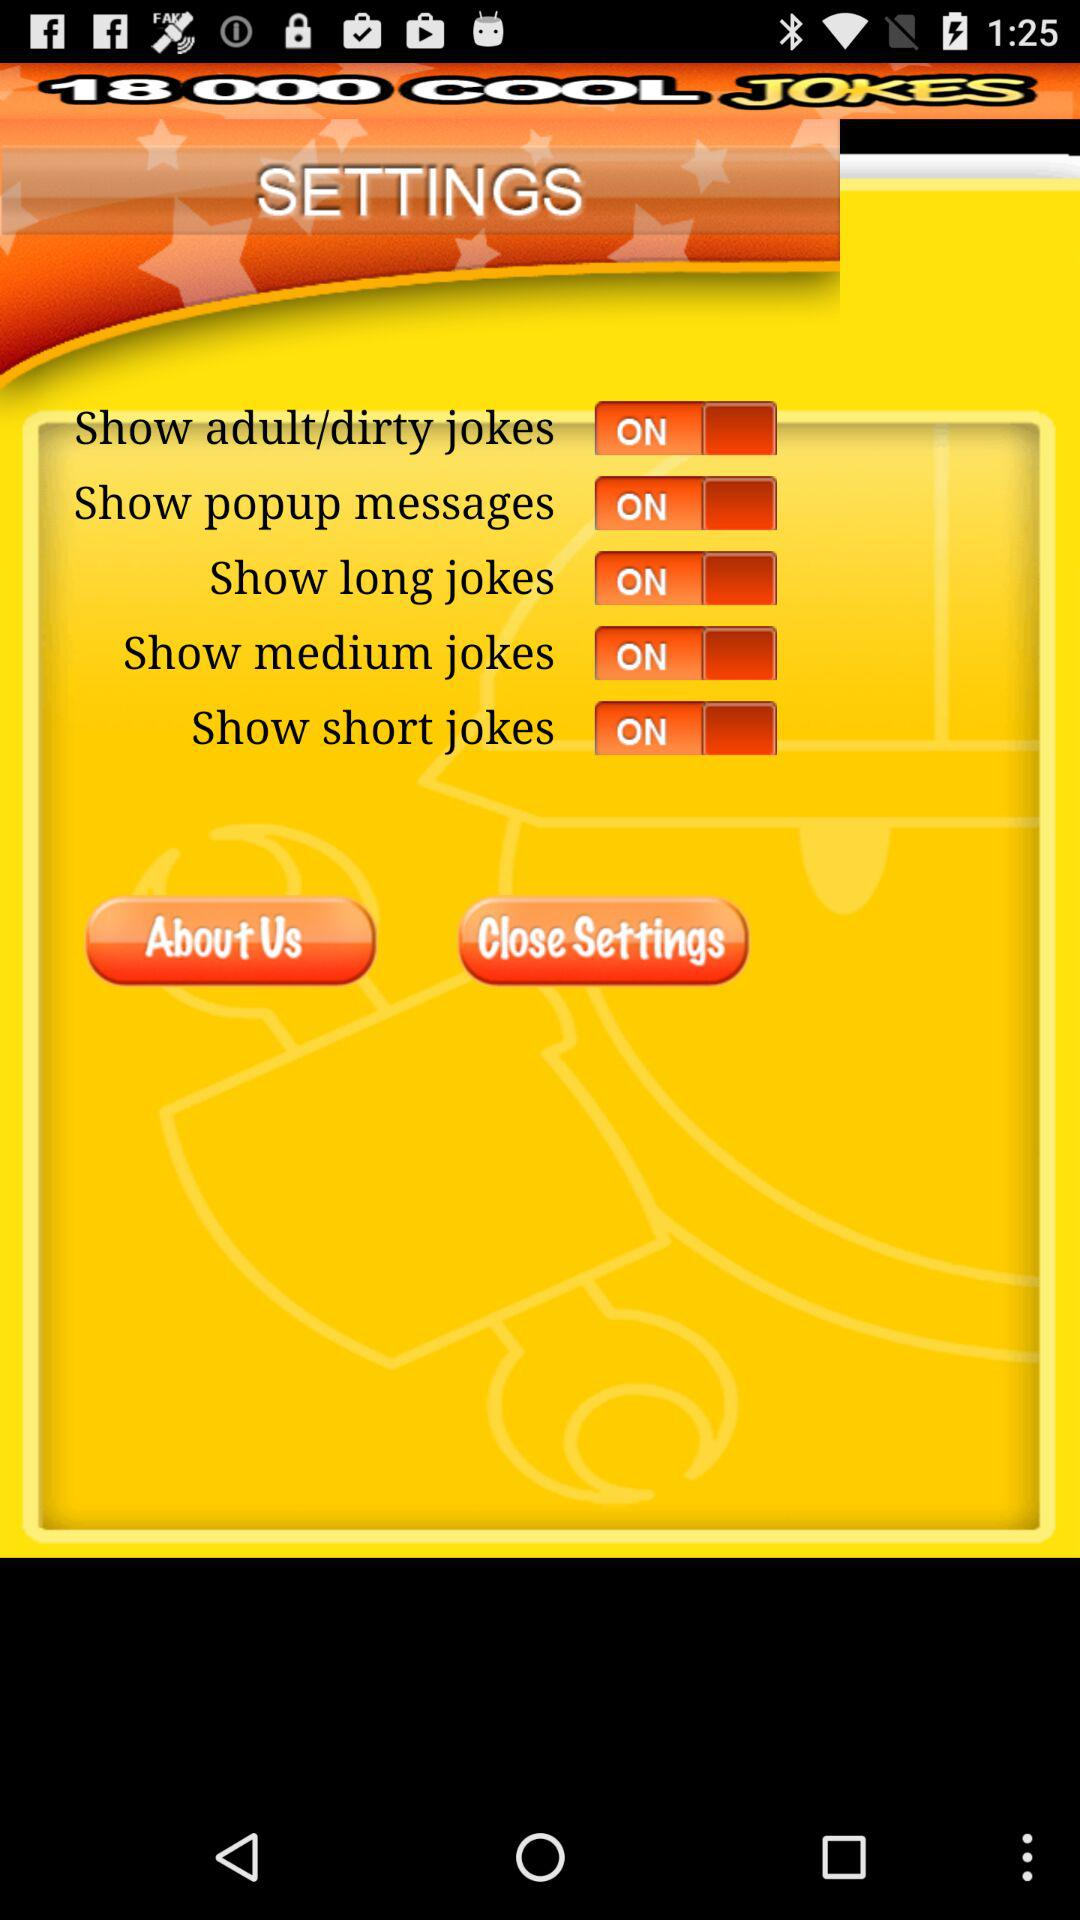How many total number of cool jokes are there?
When the provided information is insufficient, respond with <no answer>. <no answer> 